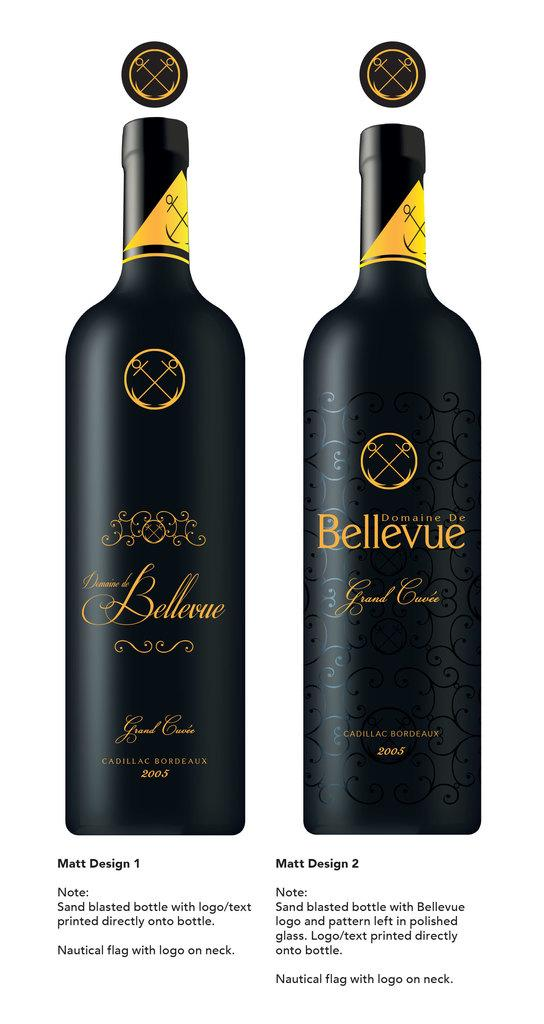<image>
Create a compact narrative representing the image presented. Bottle of wine with the word "Bellevue" on it. 